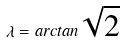Convert formula to latex. <formula><loc_0><loc_0><loc_500><loc_500>\lambda = a r c t a n \sqrt { 2 }</formula> 